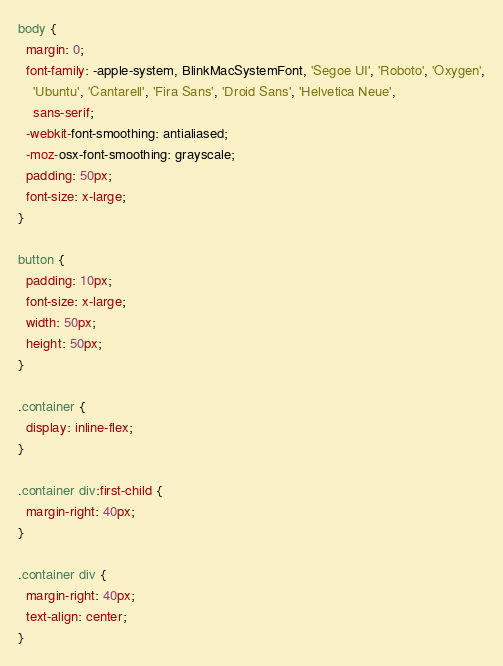Convert code to text. <code><loc_0><loc_0><loc_500><loc_500><_CSS_>body {
  margin: 0;
  font-family: -apple-system, BlinkMacSystemFont, 'Segoe UI', 'Roboto', 'Oxygen',
    'Ubuntu', 'Cantarell', 'Fira Sans', 'Droid Sans', 'Helvetica Neue',
    sans-serif;
  -webkit-font-smoothing: antialiased;
  -moz-osx-font-smoothing: grayscale;
  padding: 50px;
  font-size: x-large;
}

button {
  padding: 10px;
  font-size: x-large;
  width: 50px;
  height: 50px;
}

.container {
  display: inline-flex;
}

.container div:first-child {
  margin-right: 40px;
}

.container div {
  margin-right: 40px;
  text-align: center;
}
</code> 